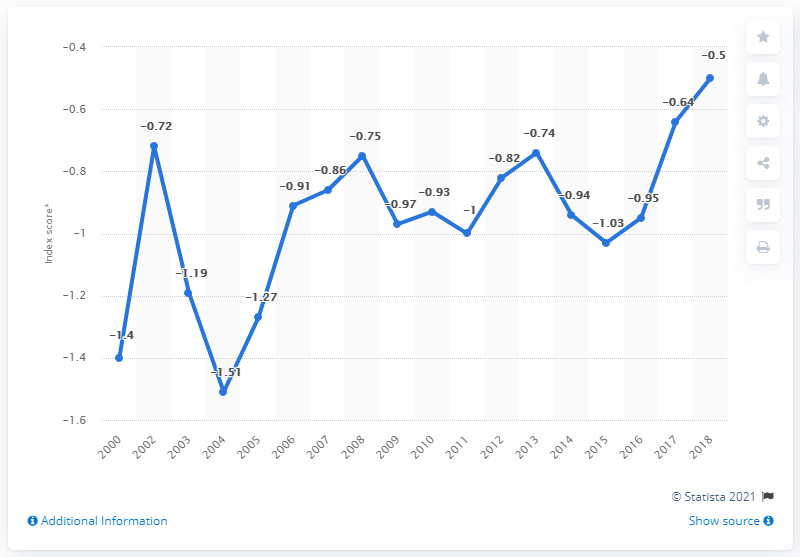Outline some significant characteristics in this image. In the 2004 Olympic Games, Russia's lowest score was -1.51. The highest point in the chart is -0.5. The difference between the lowest and highest points in the chart is 1.01. In 2018, Russia received a negative index point for its political stability and absence of violence and terrorism, indicating a decline in these measures compared to the previous year. 